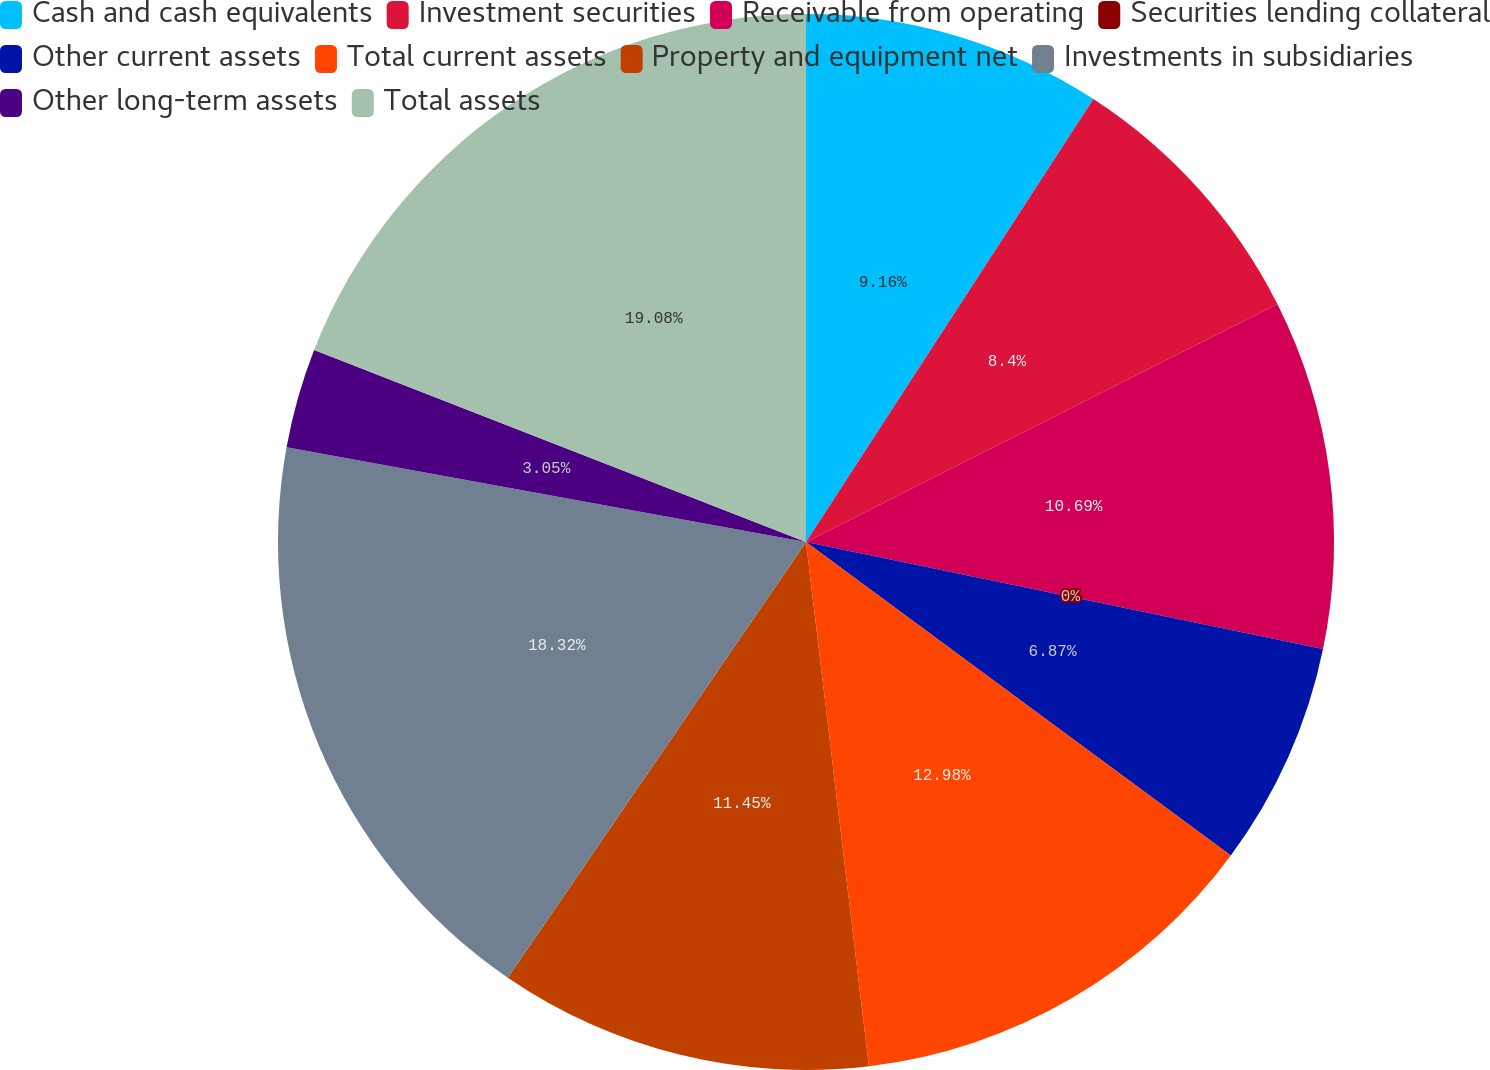Convert chart. <chart><loc_0><loc_0><loc_500><loc_500><pie_chart><fcel>Cash and cash equivalents<fcel>Investment securities<fcel>Receivable from operating<fcel>Securities lending collateral<fcel>Other current assets<fcel>Total current assets<fcel>Property and equipment net<fcel>Investments in subsidiaries<fcel>Other long-term assets<fcel>Total assets<nl><fcel>9.16%<fcel>8.4%<fcel>10.69%<fcel>0.0%<fcel>6.87%<fcel>12.98%<fcel>11.45%<fcel>18.32%<fcel>3.05%<fcel>19.08%<nl></chart> 